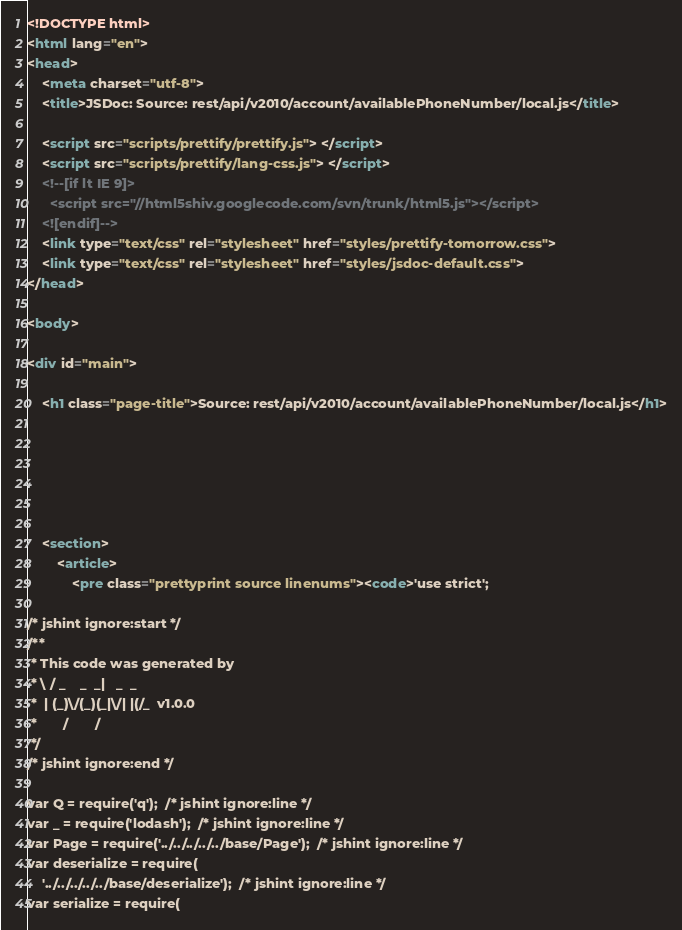Convert code to text. <code><loc_0><loc_0><loc_500><loc_500><_HTML_><!DOCTYPE html>
<html lang="en">
<head>
    <meta charset="utf-8">
    <title>JSDoc: Source: rest/api/v2010/account/availablePhoneNumber/local.js</title>

    <script src="scripts/prettify/prettify.js"> </script>
    <script src="scripts/prettify/lang-css.js"> </script>
    <!--[if lt IE 9]>
      <script src="//html5shiv.googlecode.com/svn/trunk/html5.js"></script>
    <![endif]-->
    <link type="text/css" rel="stylesheet" href="styles/prettify-tomorrow.css">
    <link type="text/css" rel="stylesheet" href="styles/jsdoc-default.css">
</head>

<body>

<div id="main">

    <h1 class="page-title">Source: rest/api/v2010/account/availablePhoneNumber/local.js</h1>

    



    
    <section>
        <article>
            <pre class="prettyprint source linenums"><code>'use strict';

/* jshint ignore:start */
/**
 * This code was generated by
 * \ / _    _  _|   _  _
 *  | (_)\/(_)(_|\/| |(/_  v1.0.0
 *       /       /
 */
/* jshint ignore:end */

var Q = require('q');  /* jshint ignore:line */
var _ = require('lodash');  /* jshint ignore:line */
var Page = require('../../../../../base/Page');  /* jshint ignore:line */
var deserialize = require(
    '../../../../../base/deserialize');  /* jshint ignore:line */
var serialize = require(</code> 